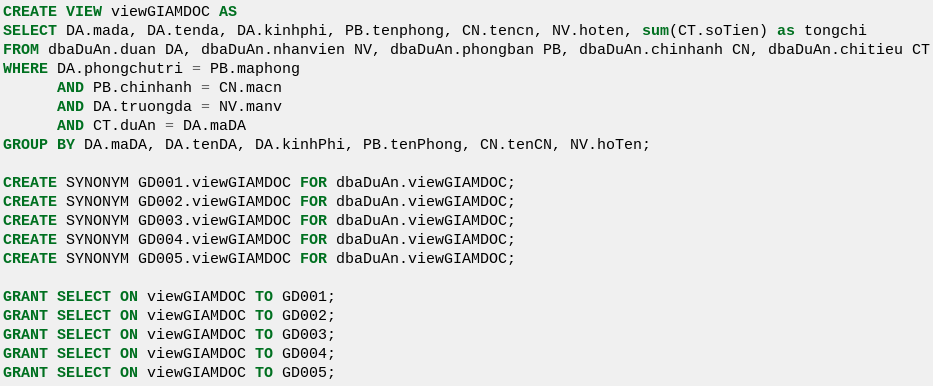Convert code to text. <code><loc_0><loc_0><loc_500><loc_500><_SQL_>CREATE VIEW viewGIAMDOC AS
SELECT DA.mada, DA.tenda, DA.kinhphi, PB.tenphong, CN.tencn, NV.hoten, sum(CT.soTien) as tongchi
FROM dbaDuAn.duan DA, dbaDuAn.nhanvien NV, dbaDuAn.phongban PB, dbaDuAn.chinhanh CN, dbaDuAn.chitieu CT
WHERE DA.phongchutri = PB.maphong
      AND PB.chinhanh = CN.macn
      AND DA.truongda = NV.manv
      AND CT.duAn = DA.maDA
GROUP BY DA.maDA, DA.tenDA, DA.kinhPhi, PB.tenPhong, CN.tenCN, NV.hoTen;
      
CREATE SYNONYM GD001.viewGIAMDOC FOR dbaDuAn.viewGIAMDOC;
CREATE SYNONYM GD002.viewGIAMDOC FOR dbaDuAn.viewGIAMDOC;
CREATE SYNONYM GD003.viewGIAMDOC FOR dbaDuAn.viewGIAMDOC;
CREATE SYNONYM GD004.viewGIAMDOC FOR dbaDuAn.viewGIAMDOC;
CREATE SYNONYM GD005.viewGIAMDOC FOR dbaDuAn.viewGIAMDOC;

GRANT SELECT ON viewGIAMDOC TO GD001;
GRANT SELECT ON viewGIAMDOC TO GD002;
GRANT SELECT ON viewGIAMDOC TO GD003;
GRANT SELECT ON viewGIAMDOC TO GD004;
GRANT SELECT ON viewGIAMDOC TO GD005;
</code> 